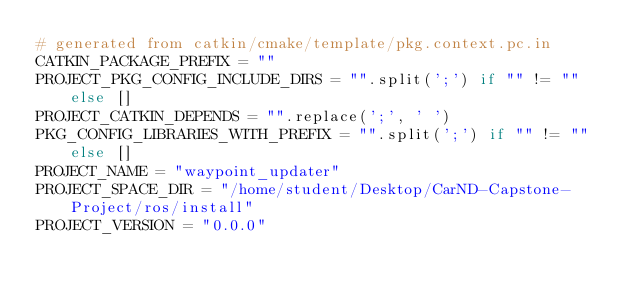Convert code to text. <code><loc_0><loc_0><loc_500><loc_500><_Python_># generated from catkin/cmake/template/pkg.context.pc.in
CATKIN_PACKAGE_PREFIX = ""
PROJECT_PKG_CONFIG_INCLUDE_DIRS = "".split(';') if "" != "" else []
PROJECT_CATKIN_DEPENDS = "".replace(';', ' ')
PKG_CONFIG_LIBRARIES_WITH_PREFIX = "".split(';') if "" != "" else []
PROJECT_NAME = "waypoint_updater"
PROJECT_SPACE_DIR = "/home/student/Desktop/CarND-Capstone-Project/ros/install"
PROJECT_VERSION = "0.0.0"
</code> 